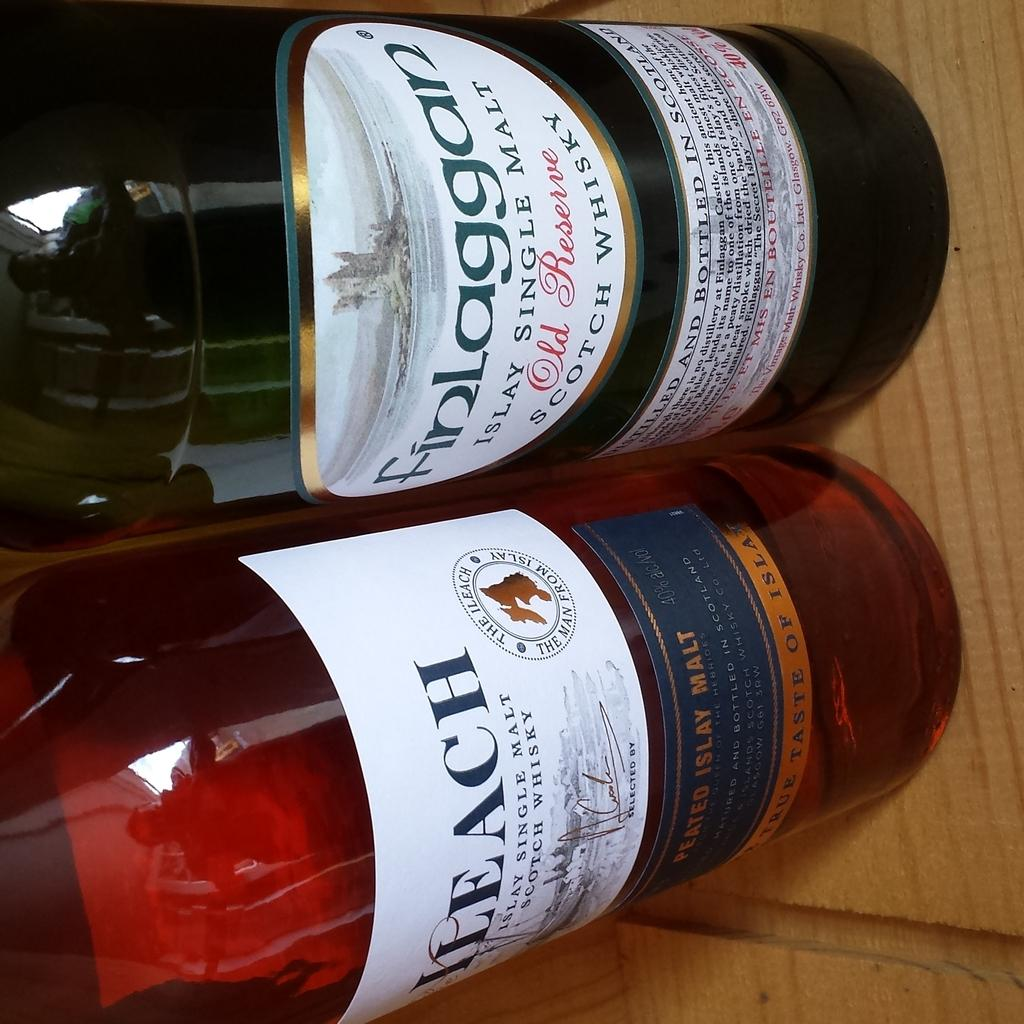<image>
Offer a succinct explanation of the picture presented. A couple of bottles sit next to each other on the table and one says Finlaggan 